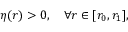<formula> <loc_0><loc_0><loc_500><loc_500>\eta ( r ) > 0 , \quad \forall r \in [ r _ { 0 } , r _ { 1 } ] ,</formula> 